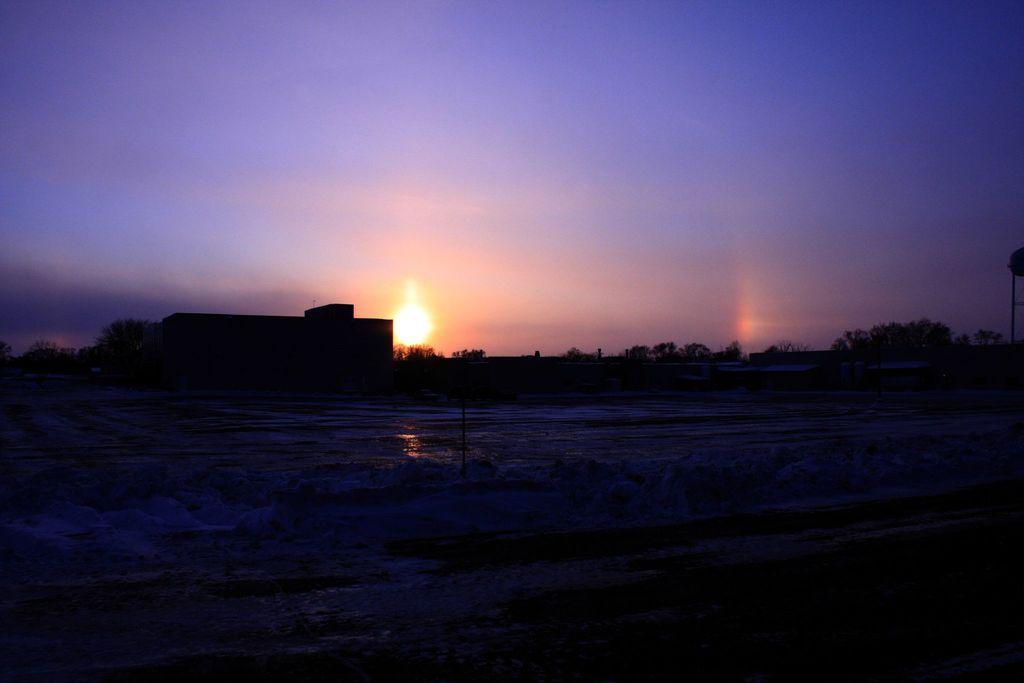How would you summarize this image in a sentence or two? In this image we can see a building. We can see the sun in the sky. There are many trees in the image. 